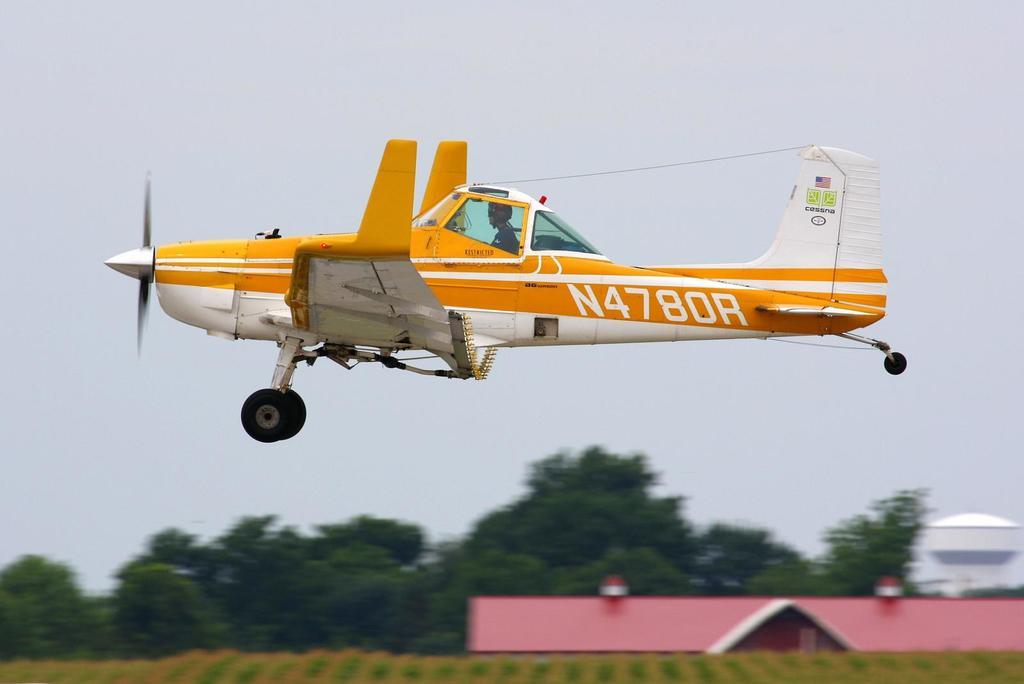What is the plane number?
Provide a succinct answer. N4780r. 